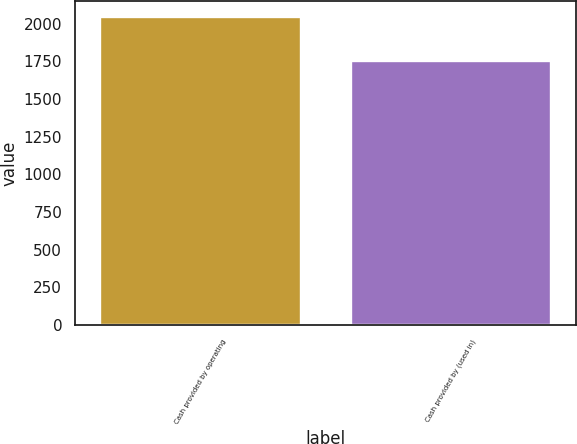Convert chart to OTSL. <chart><loc_0><loc_0><loc_500><loc_500><bar_chart><fcel>Cash provided by operating<fcel>Cash provided by (used in)<nl><fcel>2044.6<fcel>1754<nl></chart> 